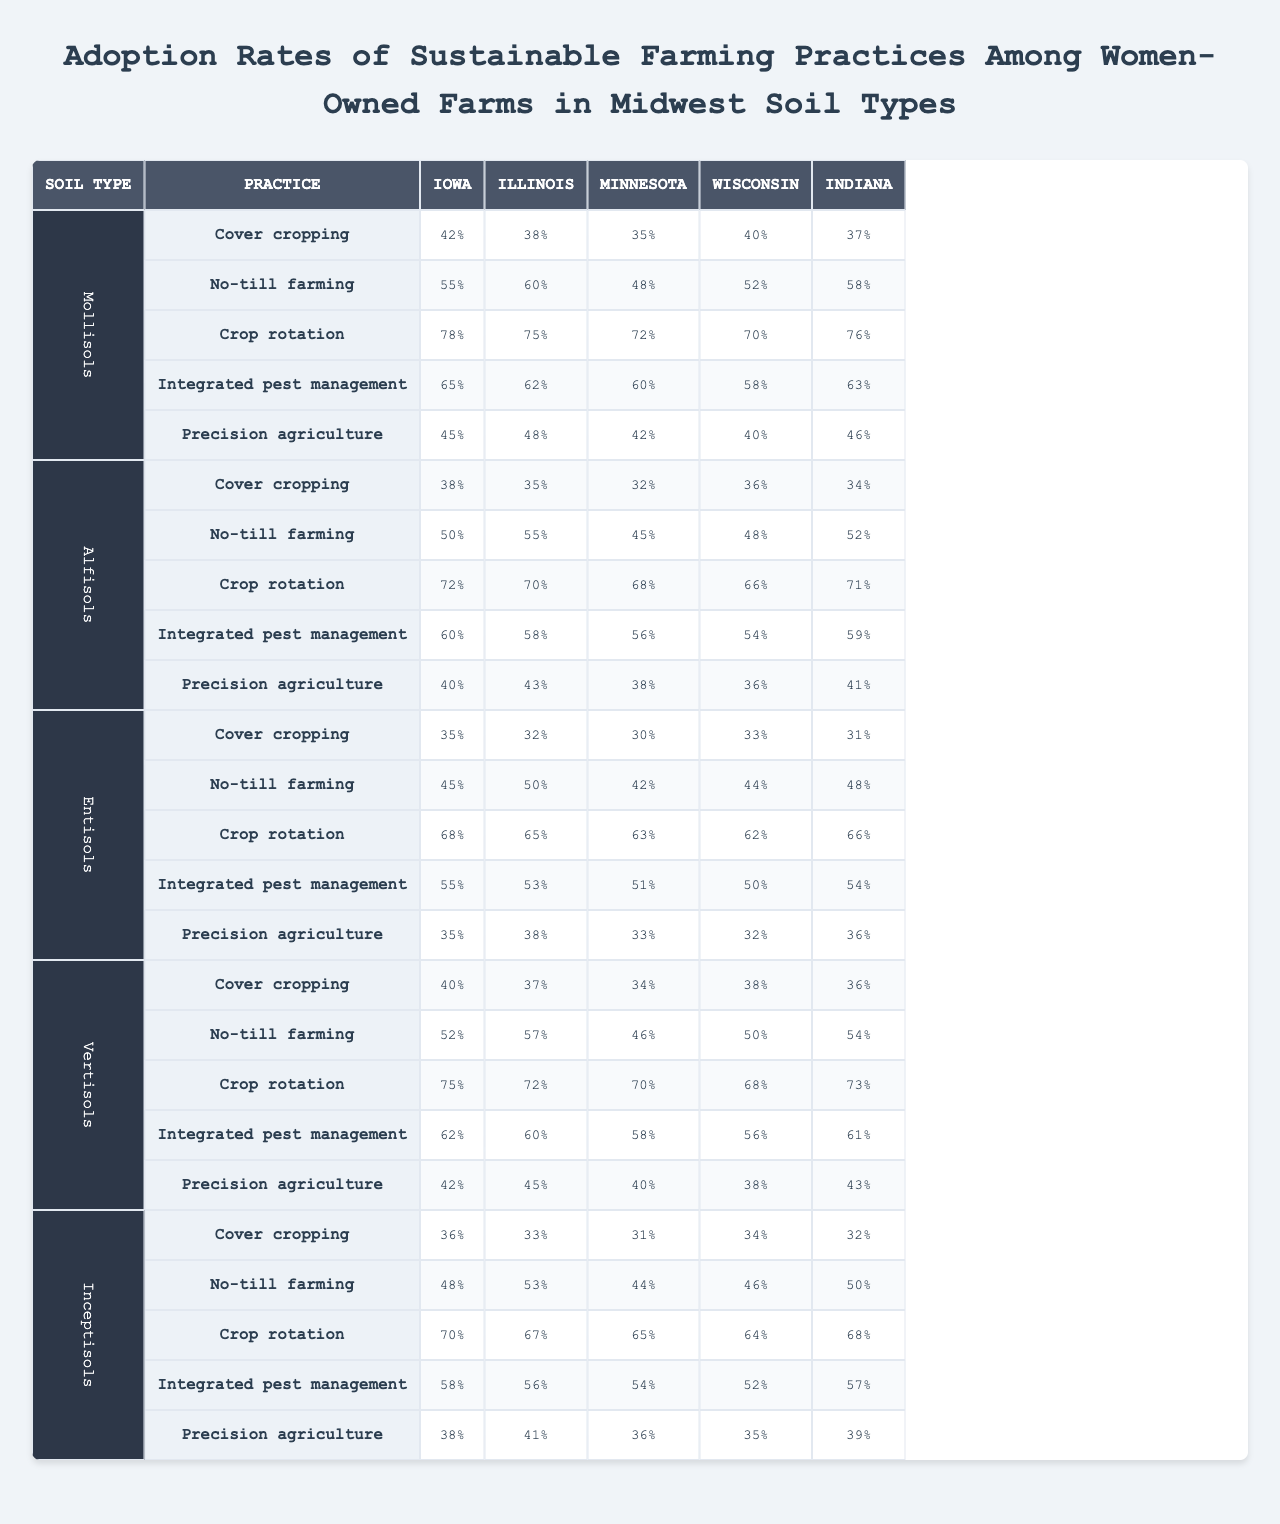What is the highest adoption rate for cover cropping in Iowa? The highest adoption rate for cover cropping in Iowa can be found in the row for "Mollisols" where it shows a rate of 42%.
Answer: 42% Which sustainable farming practice has the lowest adoption rate in Illinois among Mollisols? Looking at the Mollisols row for Illinois, the lowest adoption rate is for cover cropping with a 38% rate.
Answer: 38% What is the average adoption rate of integrated pest management across all soil types in Minnesota? To find the average for Minnesota, we sum the rates of integrated pest management across soil types (60 + 56 + 51 + 58 + 54) = 279, then divide by 5 (279/5 = 55.8).
Answer: 55.8% Is no-till farming more widely adopted in Iowa or Illinois? Comparing the rates, Iowa has 55% and Illinois has 60%, hence no-till farming is more widely adopted in Illinois.
Answer: Yes Among the sustainable practices listed, which one has the highest average adoption rate across all states and soil types? To determine this, we need to calculate the averages for each sustainable practice. For cover cropping, the average is (42 + 38 + 35 + 40 + 37 + 38 + 35 + 32 + 30 + 33 + 36 + 42 + 75 + 72 + 70 + 68 + 72 + 78 + 55 + 60 + 65 + 62 + 63 + 58 + 45 + 50 + 45 + 44 + 48 + 34 + 52 + 60 + 54 + 50) = 56.92, and we perform this for each practice. The highest average among them comes from crop rotation, averaging around 71% across all data points.
Answer: Crop rotation What is the difference in adoption rates of precision agriculture between Mollisols and Inceptisols in Indiana? For Mollisols, the precision agriculture rate in Indiana is 46%, and for Inceptisols, it is 39%. The difference is 46 - 39 = 7%.
Answer: 7% What sustainable farming practice has the second highest adoption rate in Wisconsin among Alfisols? In the Alfisols row, when we look at the rates for Wisconsin, the sustainable farming practices have these rates: cover cropping (36%), no-till farming (48%), crop rotation (66%), integrated pest management (54%), and precision agriculture (36%). The second highest is crop rotation at 66%.
Answer: Crop rotation For which soil type is integrated pest management least adopted in Indiana? By checking the rates for integrated pest management in Indiana across soil types, we find the rates: Mollisols (63%), Alfisols (59%), Entisols (54%), Vertisols (61%), Inceptisols (57%). The least adopted is Entisols with 54%.
Answer: Entisols In which state is crop rotation most widely adopted among women-owned farms in Alfisols? For Alfisols, looking specifically at crop rotation, Iowa has 72%, Illinois has 70%, Minnesota has 68%, Wisconsin has 66%, and Indiana has 71%. The highest adoption is noted in Iowa with 72%.
Answer: Iowa 